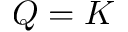Convert formula to latex. <formula><loc_0><loc_0><loc_500><loc_500>Q = K</formula> 